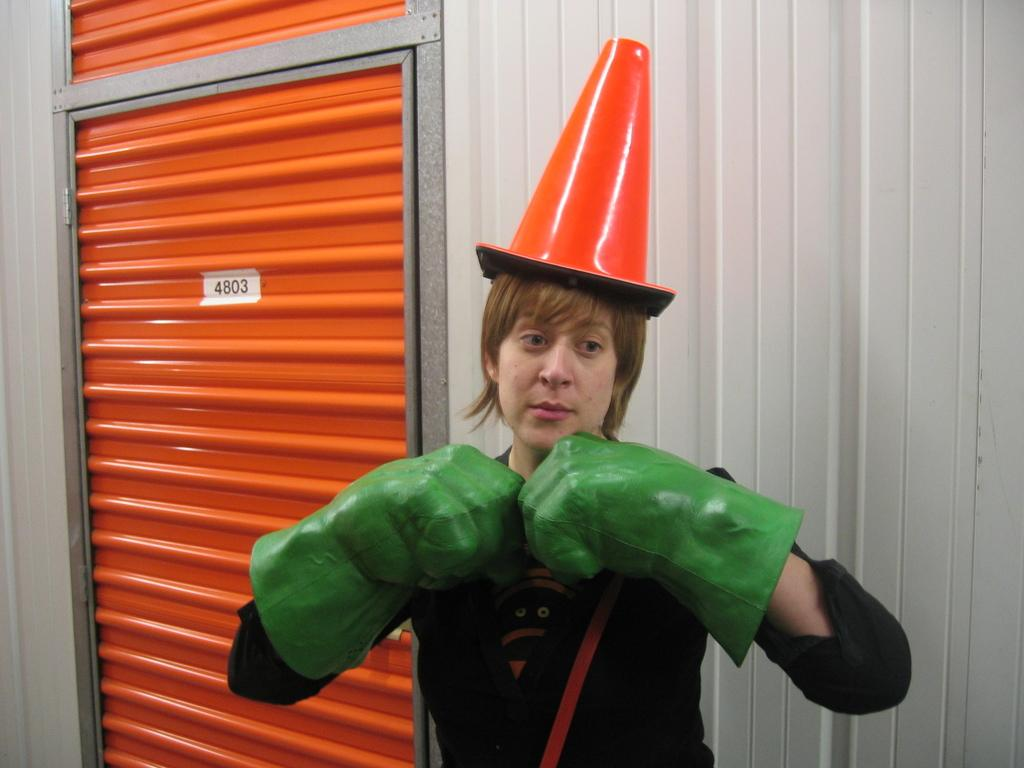Who is present in the image? There is a lady in the image. What is the lady wearing on her head? The lady is wearing a hat. What is the lady wearing on her hands? The lady is wearing hand gloves. What type of structure can be seen in the image? There is a wall with a door in the image. Are there any numbers visible in the image? Yes, there are numbers on the wall or door. Can you see a window in the image? There is no mention of a window in the provided facts, so we cannot determine if a window is present in the image. Is there a girl in the image? The facts only mention a lady, so we cannot determine if there is a girl in the image. 